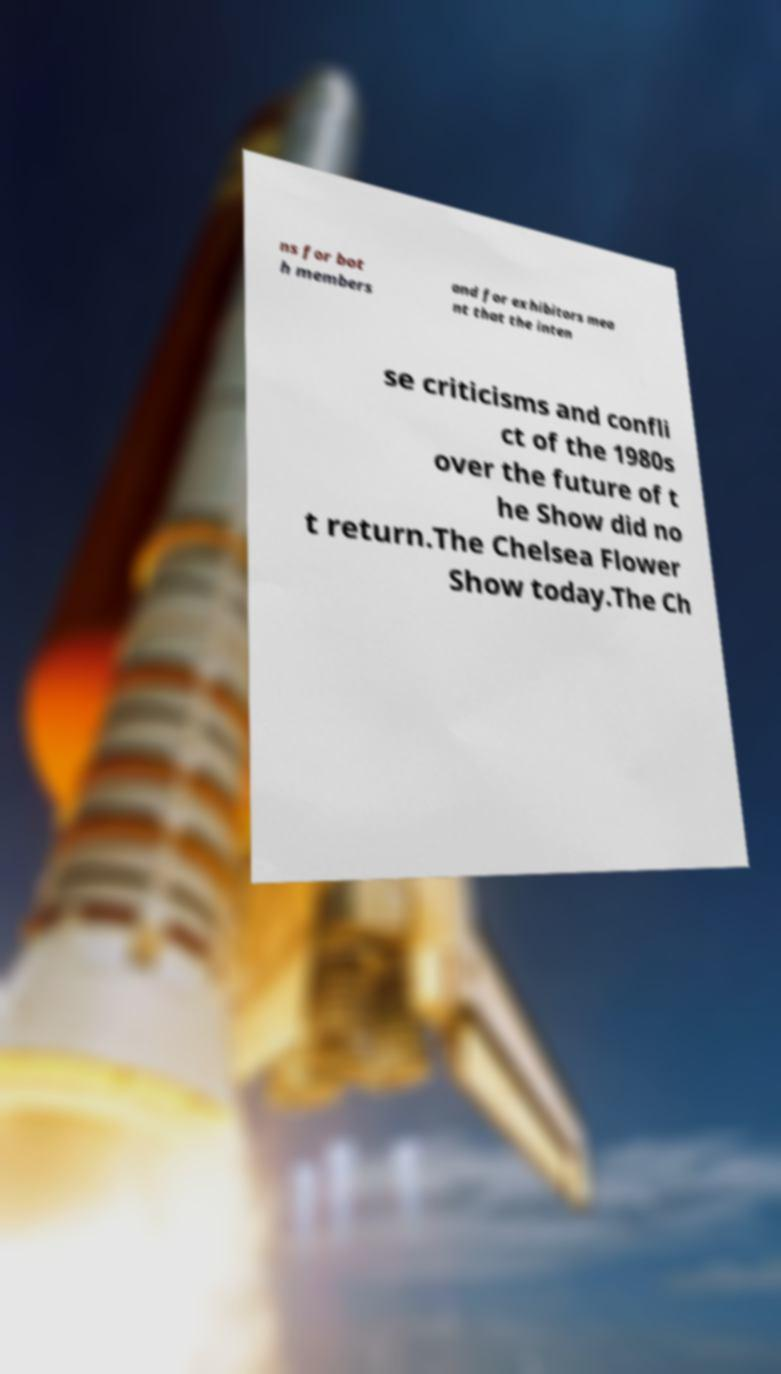Please identify and transcribe the text found in this image. ns for bot h members and for exhibitors mea nt that the inten se criticisms and confli ct of the 1980s over the future of t he Show did no t return.The Chelsea Flower Show today.The Ch 